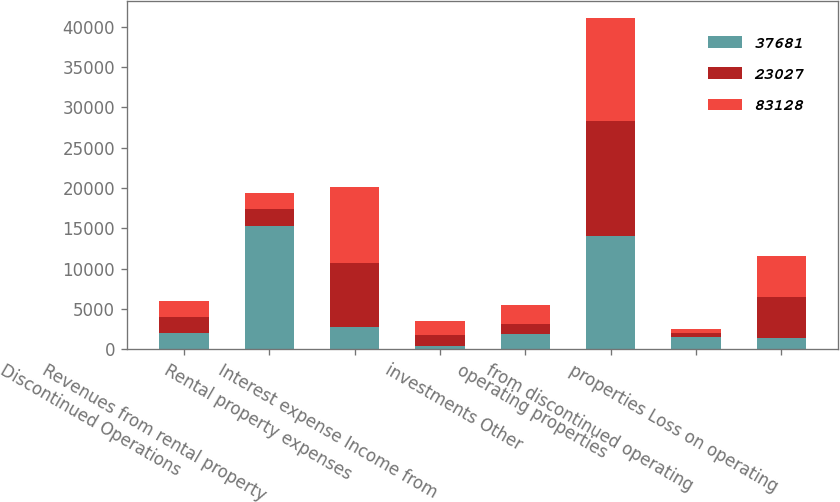Convert chart. <chart><loc_0><loc_0><loc_500><loc_500><stacked_bar_chart><ecel><fcel>Discontinued Operations<fcel>Revenues from rental property<fcel>Rental property expenses<fcel>Interest expense Income from<fcel>investments Other<fcel>operating properties<fcel>from discontinued operating<fcel>properties Loss on operating<nl><fcel>37681<fcel>2006<fcel>15318<fcel>2774<fcel>380<fcel>1832<fcel>14004<fcel>1497<fcel>1421<nl><fcel>23027<fcel>2005<fcel>2005.5<fcel>7925<fcel>1382<fcel>1305<fcel>14337<fcel>476<fcel>5098<nl><fcel>83128<fcel>2004<fcel>2005.5<fcel>9369<fcel>1779<fcel>2300<fcel>12749<fcel>481<fcel>5064<nl></chart> 